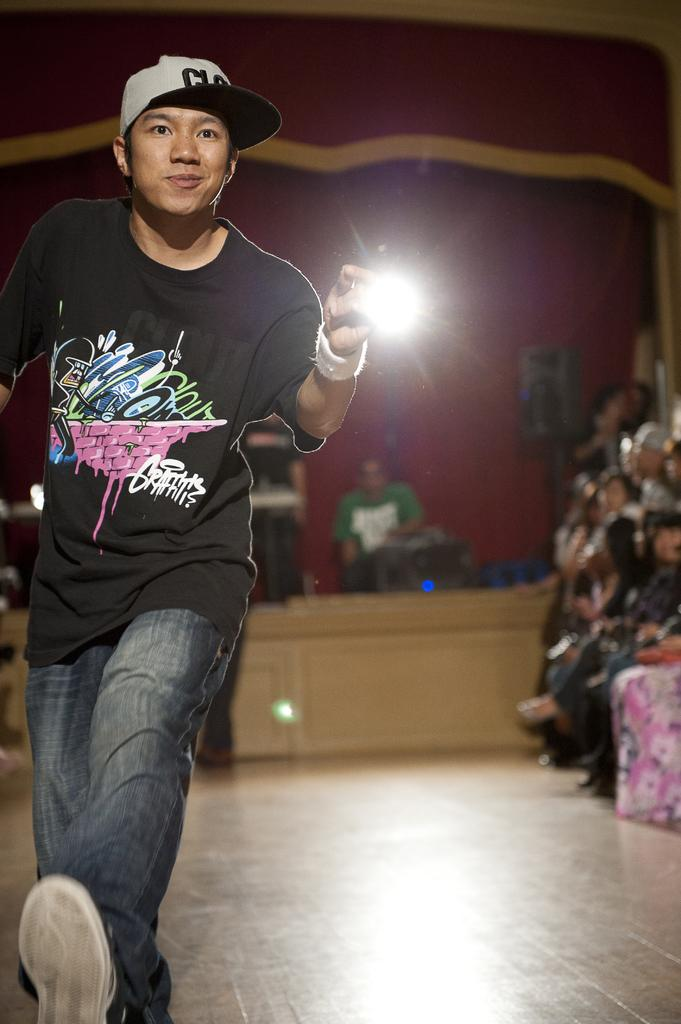Who is the main subject in the image? There is a boy in the image. What is the boy doing in the image? The boy appears to be holding an object in his hand. Can you describe the background of the image? There are other people and objects in the background of the image. What type of wing is attached to the boy in the image? There is no wing attached to the boy in the image. Is the boy a representative of a political party in the image? There is no indication in the image that the boy is a representative of a political party. 